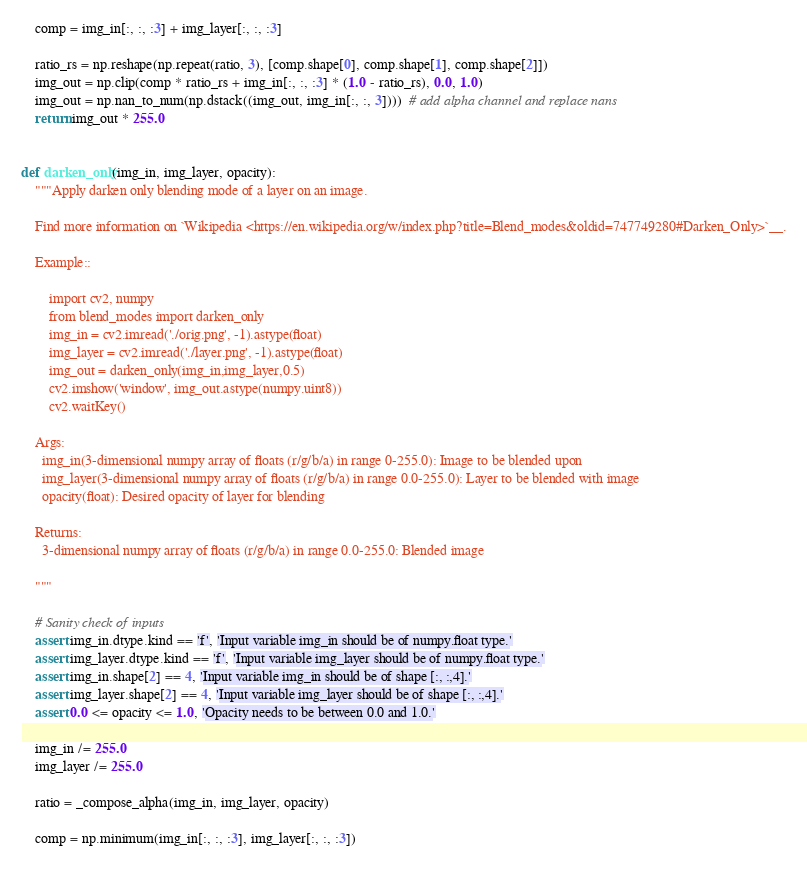Convert code to text. <code><loc_0><loc_0><loc_500><loc_500><_Python_>    comp = img_in[:, :, :3] + img_layer[:, :, :3]

    ratio_rs = np.reshape(np.repeat(ratio, 3), [comp.shape[0], comp.shape[1], comp.shape[2]])
    img_out = np.clip(comp * ratio_rs + img_in[:, :, :3] * (1.0 - ratio_rs), 0.0, 1.0)
    img_out = np.nan_to_num(np.dstack((img_out, img_in[:, :, 3])))  # add alpha channel and replace nans
    return img_out * 255.0


def darken_only(img_in, img_layer, opacity):
    """Apply darken only blending mode of a layer on an image.

    Find more information on `Wikipedia <https://en.wikipedia.org/w/index.php?title=Blend_modes&oldid=747749280#Darken_Only>`__.

    Example::

        import cv2, numpy
        from blend_modes import darken_only
        img_in = cv2.imread('./orig.png', -1).astype(float)
        img_layer = cv2.imread('./layer.png', -1).astype(float)
        img_out = darken_only(img_in,img_layer,0.5)
        cv2.imshow('window', img_out.astype(numpy.uint8))
        cv2.waitKey()

    Args:
      img_in(3-dimensional numpy array of floats (r/g/b/a) in range 0-255.0): Image to be blended upon
      img_layer(3-dimensional numpy array of floats (r/g/b/a) in range 0.0-255.0): Layer to be blended with image
      opacity(float): Desired opacity of layer for blending

    Returns:
      3-dimensional numpy array of floats (r/g/b/a) in range 0.0-255.0: Blended image

    """

    # Sanity check of inputs
    assert img_in.dtype.kind == 'f', 'Input variable img_in should be of numpy.float type.'
    assert img_layer.dtype.kind == 'f', 'Input variable img_layer should be of numpy.float type.'
    assert img_in.shape[2] == 4, 'Input variable img_in should be of shape [:, :,4].'
    assert img_layer.shape[2] == 4, 'Input variable img_layer should be of shape [:, :,4].'
    assert 0.0 <= opacity <= 1.0, 'Opacity needs to be between 0.0 and 1.0.'

    img_in /= 255.0
    img_layer /= 255.0

    ratio = _compose_alpha(img_in, img_layer, opacity)

    comp = np.minimum(img_in[:, :, :3], img_layer[:, :, :3])
</code> 